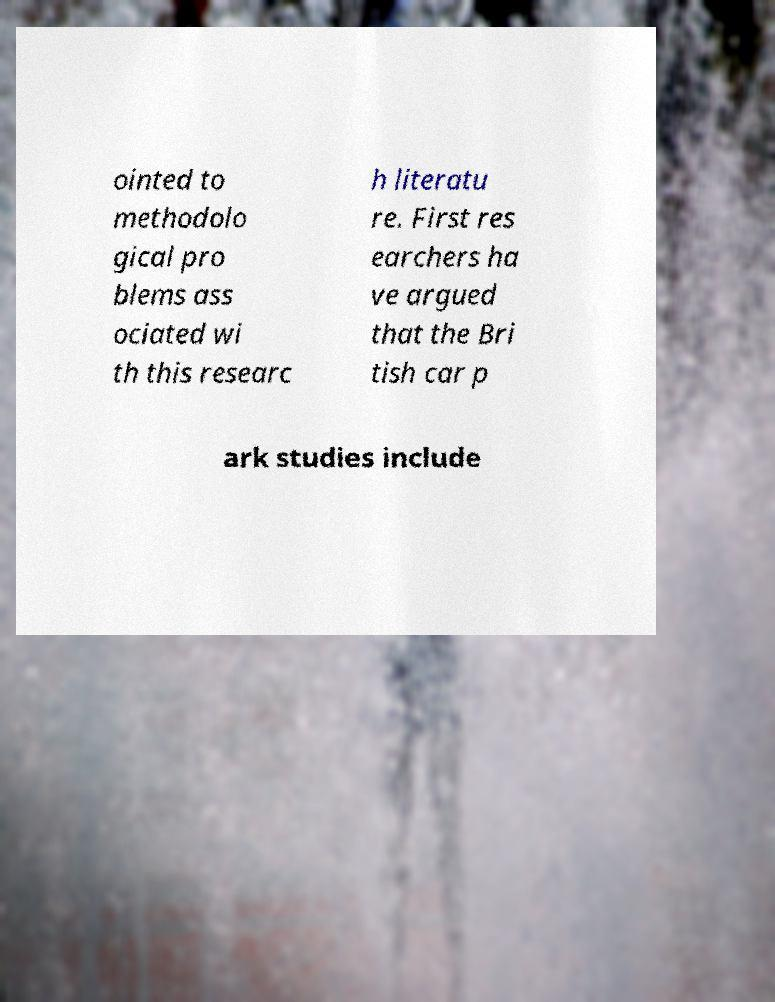For documentation purposes, I need the text within this image transcribed. Could you provide that? ointed to methodolo gical pro blems ass ociated wi th this researc h literatu re. First res earchers ha ve argued that the Bri tish car p ark studies include 